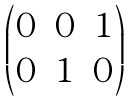Convert formula to latex. <formula><loc_0><loc_0><loc_500><loc_500>\begin{pmatrix} 0 & 0 & 1 \\ 0 & 1 & 0 \end{pmatrix}</formula> 